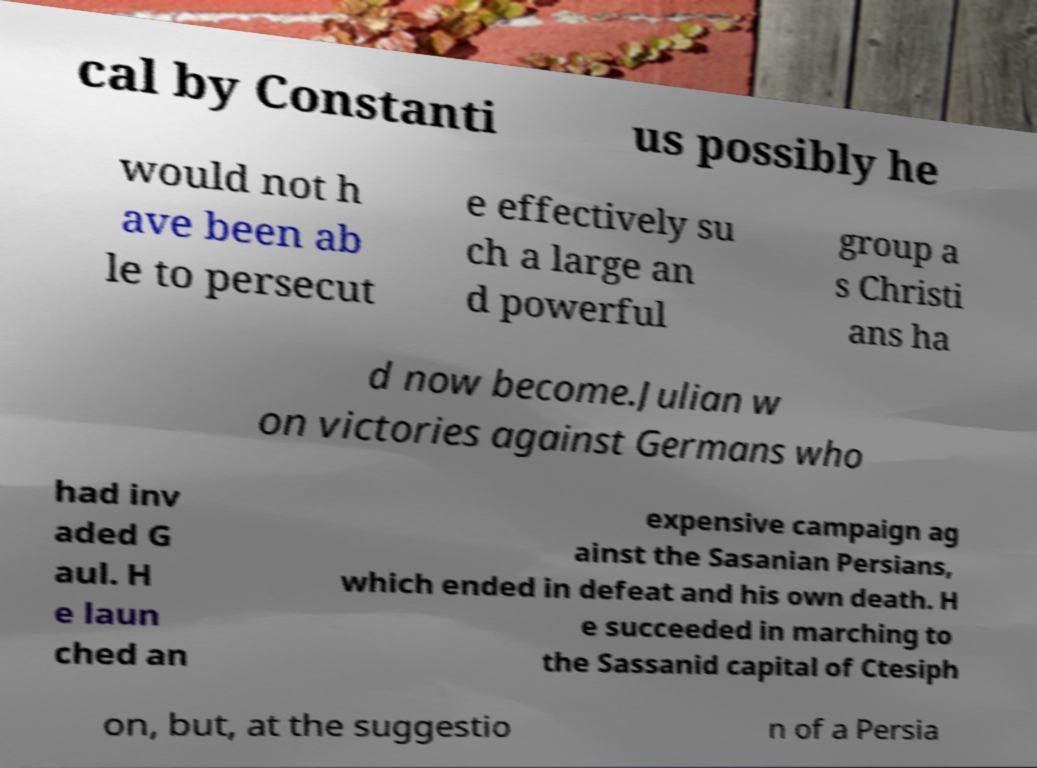I need the written content from this picture converted into text. Can you do that? cal by Constanti us possibly he would not h ave been ab le to persecut e effectively su ch a large an d powerful group a s Christi ans ha d now become.Julian w on victories against Germans who had inv aded G aul. H e laun ched an expensive campaign ag ainst the Sasanian Persians, which ended in defeat and his own death. H e succeeded in marching to the Sassanid capital of Ctesiph on, but, at the suggestio n of a Persia 